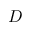Convert formula to latex. <formula><loc_0><loc_0><loc_500><loc_500>D</formula> 